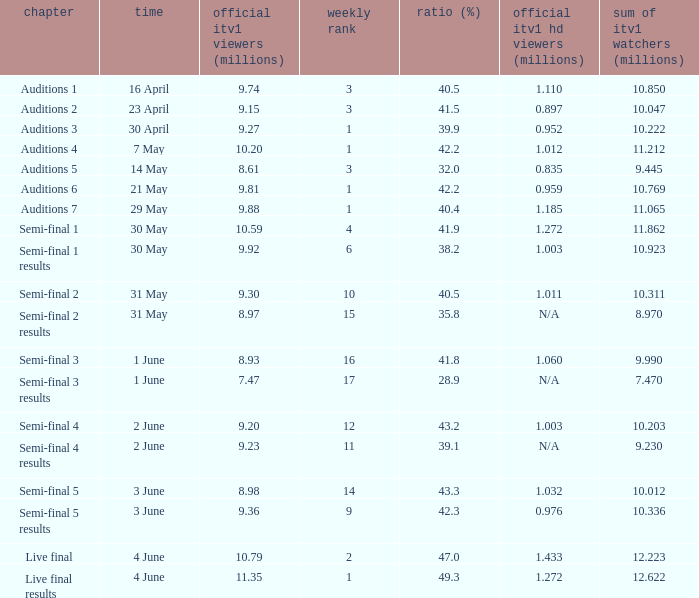When was the episode that had a share (%) of 41.5? 23 April. 